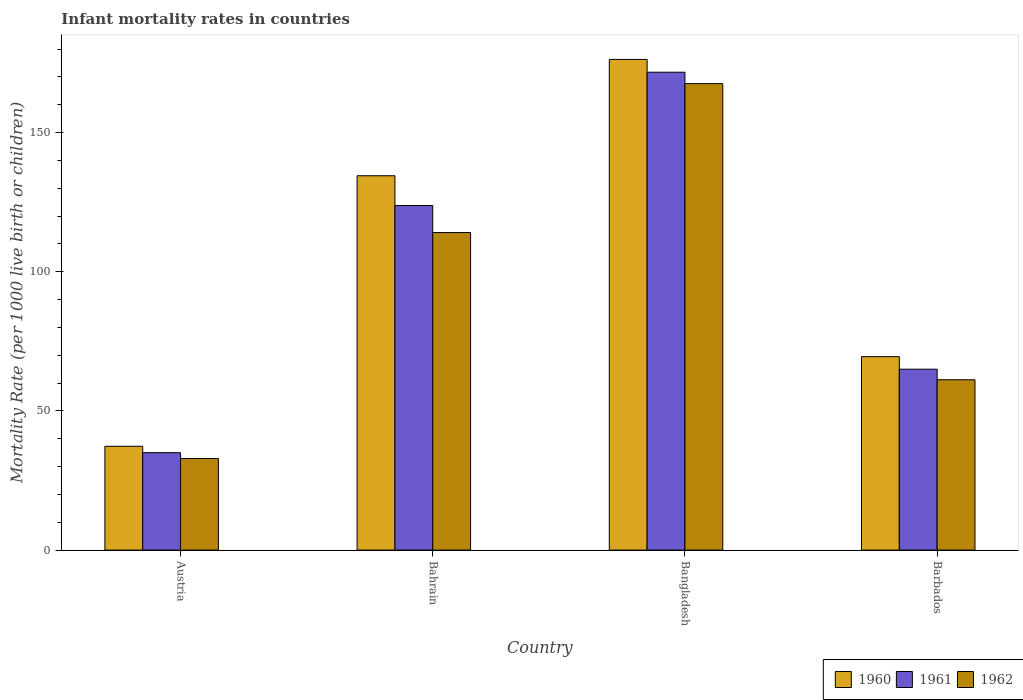How many different coloured bars are there?
Your answer should be very brief. 3. How many bars are there on the 2nd tick from the left?
Your response must be concise. 3. What is the label of the 2nd group of bars from the left?
Your answer should be very brief. Bahrain. In how many cases, is the number of bars for a given country not equal to the number of legend labels?
Keep it short and to the point. 0. What is the infant mortality rate in 1961 in Bangladesh?
Your answer should be very brief. 171.7. Across all countries, what is the maximum infant mortality rate in 1962?
Offer a very short reply. 167.6. Across all countries, what is the minimum infant mortality rate in 1962?
Provide a succinct answer. 32.9. What is the total infant mortality rate in 1960 in the graph?
Your answer should be very brief. 417.6. What is the difference between the infant mortality rate in 1960 in Austria and that in Bahrain?
Offer a very short reply. -97.2. What is the difference between the infant mortality rate in 1962 in Bangladesh and the infant mortality rate in 1960 in Austria?
Your answer should be compact. 130.3. What is the average infant mortality rate in 1961 per country?
Provide a short and direct response. 98.88. What is the difference between the infant mortality rate of/in 1961 and infant mortality rate of/in 1962 in Austria?
Keep it short and to the point. 2.1. In how many countries, is the infant mortality rate in 1961 greater than 90?
Keep it short and to the point. 2. What is the ratio of the infant mortality rate in 1961 in Austria to that in Bangladesh?
Provide a succinct answer. 0.2. What is the difference between the highest and the second highest infant mortality rate in 1962?
Your answer should be very brief. 52.9. What is the difference between the highest and the lowest infant mortality rate in 1961?
Offer a very short reply. 136.7. How many bars are there?
Your answer should be very brief. 12. How many countries are there in the graph?
Make the answer very short. 4. What is the difference between two consecutive major ticks on the Y-axis?
Make the answer very short. 50. How are the legend labels stacked?
Keep it short and to the point. Horizontal. What is the title of the graph?
Ensure brevity in your answer.  Infant mortality rates in countries. Does "1998" appear as one of the legend labels in the graph?
Offer a very short reply. No. What is the label or title of the X-axis?
Offer a terse response. Country. What is the label or title of the Y-axis?
Your answer should be very brief. Mortality Rate (per 1000 live birth or children). What is the Mortality Rate (per 1000 live birth or children) of 1960 in Austria?
Offer a terse response. 37.3. What is the Mortality Rate (per 1000 live birth or children) of 1962 in Austria?
Give a very brief answer. 32.9. What is the Mortality Rate (per 1000 live birth or children) of 1960 in Bahrain?
Provide a short and direct response. 134.5. What is the Mortality Rate (per 1000 live birth or children) of 1961 in Bahrain?
Ensure brevity in your answer.  123.8. What is the Mortality Rate (per 1000 live birth or children) of 1962 in Bahrain?
Your response must be concise. 114.1. What is the Mortality Rate (per 1000 live birth or children) in 1960 in Bangladesh?
Make the answer very short. 176.3. What is the Mortality Rate (per 1000 live birth or children) of 1961 in Bangladesh?
Make the answer very short. 171.7. What is the Mortality Rate (per 1000 live birth or children) in 1962 in Bangladesh?
Give a very brief answer. 167.6. What is the Mortality Rate (per 1000 live birth or children) of 1960 in Barbados?
Offer a very short reply. 69.5. What is the Mortality Rate (per 1000 live birth or children) in 1961 in Barbados?
Offer a terse response. 65. What is the Mortality Rate (per 1000 live birth or children) of 1962 in Barbados?
Provide a succinct answer. 61.2. Across all countries, what is the maximum Mortality Rate (per 1000 live birth or children) in 1960?
Keep it short and to the point. 176.3. Across all countries, what is the maximum Mortality Rate (per 1000 live birth or children) of 1961?
Keep it short and to the point. 171.7. Across all countries, what is the maximum Mortality Rate (per 1000 live birth or children) in 1962?
Your answer should be very brief. 167.6. Across all countries, what is the minimum Mortality Rate (per 1000 live birth or children) of 1960?
Offer a terse response. 37.3. Across all countries, what is the minimum Mortality Rate (per 1000 live birth or children) in 1962?
Keep it short and to the point. 32.9. What is the total Mortality Rate (per 1000 live birth or children) of 1960 in the graph?
Provide a succinct answer. 417.6. What is the total Mortality Rate (per 1000 live birth or children) in 1961 in the graph?
Provide a succinct answer. 395.5. What is the total Mortality Rate (per 1000 live birth or children) of 1962 in the graph?
Ensure brevity in your answer.  375.8. What is the difference between the Mortality Rate (per 1000 live birth or children) in 1960 in Austria and that in Bahrain?
Provide a succinct answer. -97.2. What is the difference between the Mortality Rate (per 1000 live birth or children) in 1961 in Austria and that in Bahrain?
Ensure brevity in your answer.  -88.8. What is the difference between the Mortality Rate (per 1000 live birth or children) of 1962 in Austria and that in Bahrain?
Ensure brevity in your answer.  -81.2. What is the difference between the Mortality Rate (per 1000 live birth or children) of 1960 in Austria and that in Bangladesh?
Offer a terse response. -139. What is the difference between the Mortality Rate (per 1000 live birth or children) in 1961 in Austria and that in Bangladesh?
Your answer should be very brief. -136.7. What is the difference between the Mortality Rate (per 1000 live birth or children) of 1962 in Austria and that in Bangladesh?
Keep it short and to the point. -134.7. What is the difference between the Mortality Rate (per 1000 live birth or children) of 1960 in Austria and that in Barbados?
Your answer should be compact. -32.2. What is the difference between the Mortality Rate (per 1000 live birth or children) of 1962 in Austria and that in Barbados?
Provide a short and direct response. -28.3. What is the difference between the Mortality Rate (per 1000 live birth or children) of 1960 in Bahrain and that in Bangladesh?
Give a very brief answer. -41.8. What is the difference between the Mortality Rate (per 1000 live birth or children) in 1961 in Bahrain and that in Bangladesh?
Ensure brevity in your answer.  -47.9. What is the difference between the Mortality Rate (per 1000 live birth or children) in 1962 in Bahrain and that in Bangladesh?
Offer a terse response. -53.5. What is the difference between the Mortality Rate (per 1000 live birth or children) in 1960 in Bahrain and that in Barbados?
Give a very brief answer. 65. What is the difference between the Mortality Rate (per 1000 live birth or children) of 1961 in Bahrain and that in Barbados?
Provide a short and direct response. 58.8. What is the difference between the Mortality Rate (per 1000 live birth or children) in 1962 in Bahrain and that in Barbados?
Your answer should be compact. 52.9. What is the difference between the Mortality Rate (per 1000 live birth or children) in 1960 in Bangladesh and that in Barbados?
Make the answer very short. 106.8. What is the difference between the Mortality Rate (per 1000 live birth or children) in 1961 in Bangladesh and that in Barbados?
Keep it short and to the point. 106.7. What is the difference between the Mortality Rate (per 1000 live birth or children) of 1962 in Bangladesh and that in Barbados?
Provide a short and direct response. 106.4. What is the difference between the Mortality Rate (per 1000 live birth or children) in 1960 in Austria and the Mortality Rate (per 1000 live birth or children) in 1961 in Bahrain?
Ensure brevity in your answer.  -86.5. What is the difference between the Mortality Rate (per 1000 live birth or children) in 1960 in Austria and the Mortality Rate (per 1000 live birth or children) in 1962 in Bahrain?
Your answer should be compact. -76.8. What is the difference between the Mortality Rate (per 1000 live birth or children) in 1961 in Austria and the Mortality Rate (per 1000 live birth or children) in 1962 in Bahrain?
Provide a succinct answer. -79.1. What is the difference between the Mortality Rate (per 1000 live birth or children) of 1960 in Austria and the Mortality Rate (per 1000 live birth or children) of 1961 in Bangladesh?
Keep it short and to the point. -134.4. What is the difference between the Mortality Rate (per 1000 live birth or children) of 1960 in Austria and the Mortality Rate (per 1000 live birth or children) of 1962 in Bangladesh?
Ensure brevity in your answer.  -130.3. What is the difference between the Mortality Rate (per 1000 live birth or children) of 1961 in Austria and the Mortality Rate (per 1000 live birth or children) of 1962 in Bangladesh?
Make the answer very short. -132.6. What is the difference between the Mortality Rate (per 1000 live birth or children) in 1960 in Austria and the Mortality Rate (per 1000 live birth or children) in 1961 in Barbados?
Offer a very short reply. -27.7. What is the difference between the Mortality Rate (per 1000 live birth or children) of 1960 in Austria and the Mortality Rate (per 1000 live birth or children) of 1962 in Barbados?
Offer a terse response. -23.9. What is the difference between the Mortality Rate (per 1000 live birth or children) in 1961 in Austria and the Mortality Rate (per 1000 live birth or children) in 1962 in Barbados?
Keep it short and to the point. -26.2. What is the difference between the Mortality Rate (per 1000 live birth or children) of 1960 in Bahrain and the Mortality Rate (per 1000 live birth or children) of 1961 in Bangladesh?
Ensure brevity in your answer.  -37.2. What is the difference between the Mortality Rate (per 1000 live birth or children) of 1960 in Bahrain and the Mortality Rate (per 1000 live birth or children) of 1962 in Bangladesh?
Make the answer very short. -33.1. What is the difference between the Mortality Rate (per 1000 live birth or children) in 1961 in Bahrain and the Mortality Rate (per 1000 live birth or children) in 1962 in Bangladesh?
Keep it short and to the point. -43.8. What is the difference between the Mortality Rate (per 1000 live birth or children) of 1960 in Bahrain and the Mortality Rate (per 1000 live birth or children) of 1961 in Barbados?
Keep it short and to the point. 69.5. What is the difference between the Mortality Rate (per 1000 live birth or children) in 1960 in Bahrain and the Mortality Rate (per 1000 live birth or children) in 1962 in Barbados?
Your answer should be very brief. 73.3. What is the difference between the Mortality Rate (per 1000 live birth or children) in 1961 in Bahrain and the Mortality Rate (per 1000 live birth or children) in 1962 in Barbados?
Provide a short and direct response. 62.6. What is the difference between the Mortality Rate (per 1000 live birth or children) in 1960 in Bangladesh and the Mortality Rate (per 1000 live birth or children) in 1961 in Barbados?
Offer a terse response. 111.3. What is the difference between the Mortality Rate (per 1000 live birth or children) in 1960 in Bangladesh and the Mortality Rate (per 1000 live birth or children) in 1962 in Barbados?
Offer a terse response. 115.1. What is the difference between the Mortality Rate (per 1000 live birth or children) in 1961 in Bangladesh and the Mortality Rate (per 1000 live birth or children) in 1962 in Barbados?
Offer a terse response. 110.5. What is the average Mortality Rate (per 1000 live birth or children) of 1960 per country?
Your answer should be compact. 104.4. What is the average Mortality Rate (per 1000 live birth or children) of 1961 per country?
Your answer should be compact. 98.88. What is the average Mortality Rate (per 1000 live birth or children) in 1962 per country?
Your answer should be very brief. 93.95. What is the difference between the Mortality Rate (per 1000 live birth or children) of 1960 and Mortality Rate (per 1000 live birth or children) of 1961 in Austria?
Ensure brevity in your answer.  2.3. What is the difference between the Mortality Rate (per 1000 live birth or children) in 1960 and Mortality Rate (per 1000 live birth or children) in 1962 in Austria?
Your answer should be compact. 4.4. What is the difference between the Mortality Rate (per 1000 live birth or children) in 1960 and Mortality Rate (per 1000 live birth or children) in 1962 in Bahrain?
Offer a terse response. 20.4. What is the difference between the Mortality Rate (per 1000 live birth or children) in 1961 and Mortality Rate (per 1000 live birth or children) in 1962 in Bahrain?
Keep it short and to the point. 9.7. What is the difference between the Mortality Rate (per 1000 live birth or children) of 1960 and Mortality Rate (per 1000 live birth or children) of 1962 in Bangladesh?
Provide a succinct answer. 8.7. What is the difference between the Mortality Rate (per 1000 live birth or children) in 1960 and Mortality Rate (per 1000 live birth or children) in 1962 in Barbados?
Make the answer very short. 8.3. What is the ratio of the Mortality Rate (per 1000 live birth or children) of 1960 in Austria to that in Bahrain?
Your answer should be very brief. 0.28. What is the ratio of the Mortality Rate (per 1000 live birth or children) of 1961 in Austria to that in Bahrain?
Your response must be concise. 0.28. What is the ratio of the Mortality Rate (per 1000 live birth or children) of 1962 in Austria to that in Bahrain?
Your answer should be compact. 0.29. What is the ratio of the Mortality Rate (per 1000 live birth or children) of 1960 in Austria to that in Bangladesh?
Your answer should be compact. 0.21. What is the ratio of the Mortality Rate (per 1000 live birth or children) of 1961 in Austria to that in Bangladesh?
Provide a succinct answer. 0.2. What is the ratio of the Mortality Rate (per 1000 live birth or children) of 1962 in Austria to that in Bangladesh?
Offer a terse response. 0.2. What is the ratio of the Mortality Rate (per 1000 live birth or children) of 1960 in Austria to that in Barbados?
Keep it short and to the point. 0.54. What is the ratio of the Mortality Rate (per 1000 live birth or children) of 1961 in Austria to that in Barbados?
Your answer should be compact. 0.54. What is the ratio of the Mortality Rate (per 1000 live birth or children) in 1962 in Austria to that in Barbados?
Keep it short and to the point. 0.54. What is the ratio of the Mortality Rate (per 1000 live birth or children) in 1960 in Bahrain to that in Bangladesh?
Your answer should be very brief. 0.76. What is the ratio of the Mortality Rate (per 1000 live birth or children) in 1961 in Bahrain to that in Bangladesh?
Offer a very short reply. 0.72. What is the ratio of the Mortality Rate (per 1000 live birth or children) of 1962 in Bahrain to that in Bangladesh?
Provide a succinct answer. 0.68. What is the ratio of the Mortality Rate (per 1000 live birth or children) of 1960 in Bahrain to that in Barbados?
Offer a terse response. 1.94. What is the ratio of the Mortality Rate (per 1000 live birth or children) in 1961 in Bahrain to that in Barbados?
Your answer should be very brief. 1.9. What is the ratio of the Mortality Rate (per 1000 live birth or children) of 1962 in Bahrain to that in Barbados?
Your answer should be compact. 1.86. What is the ratio of the Mortality Rate (per 1000 live birth or children) of 1960 in Bangladesh to that in Barbados?
Give a very brief answer. 2.54. What is the ratio of the Mortality Rate (per 1000 live birth or children) in 1961 in Bangladesh to that in Barbados?
Offer a very short reply. 2.64. What is the ratio of the Mortality Rate (per 1000 live birth or children) in 1962 in Bangladesh to that in Barbados?
Offer a terse response. 2.74. What is the difference between the highest and the second highest Mortality Rate (per 1000 live birth or children) of 1960?
Provide a succinct answer. 41.8. What is the difference between the highest and the second highest Mortality Rate (per 1000 live birth or children) of 1961?
Offer a terse response. 47.9. What is the difference between the highest and the second highest Mortality Rate (per 1000 live birth or children) in 1962?
Offer a very short reply. 53.5. What is the difference between the highest and the lowest Mortality Rate (per 1000 live birth or children) in 1960?
Offer a terse response. 139. What is the difference between the highest and the lowest Mortality Rate (per 1000 live birth or children) of 1961?
Give a very brief answer. 136.7. What is the difference between the highest and the lowest Mortality Rate (per 1000 live birth or children) in 1962?
Your response must be concise. 134.7. 